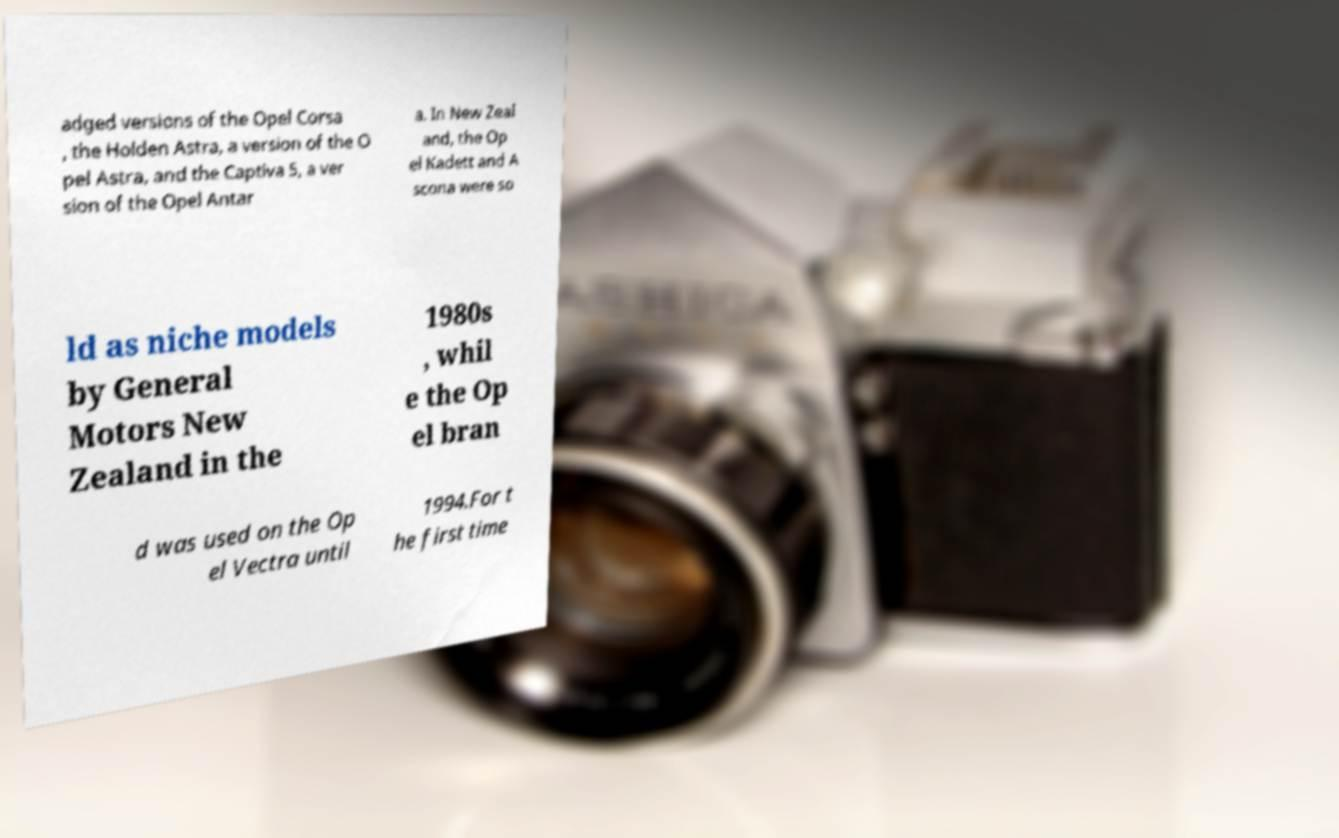Could you assist in decoding the text presented in this image and type it out clearly? adged versions of the Opel Corsa , the Holden Astra, a version of the O pel Astra, and the Captiva 5, a ver sion of the Opel Antar a. In New Zeal and, the Op el Kadett and A scona were so ld as niche models by General Motors New Zealand in the 1980s , whil e the Op el bran d was used on the Op el Vectra until 1994.For t he first time 